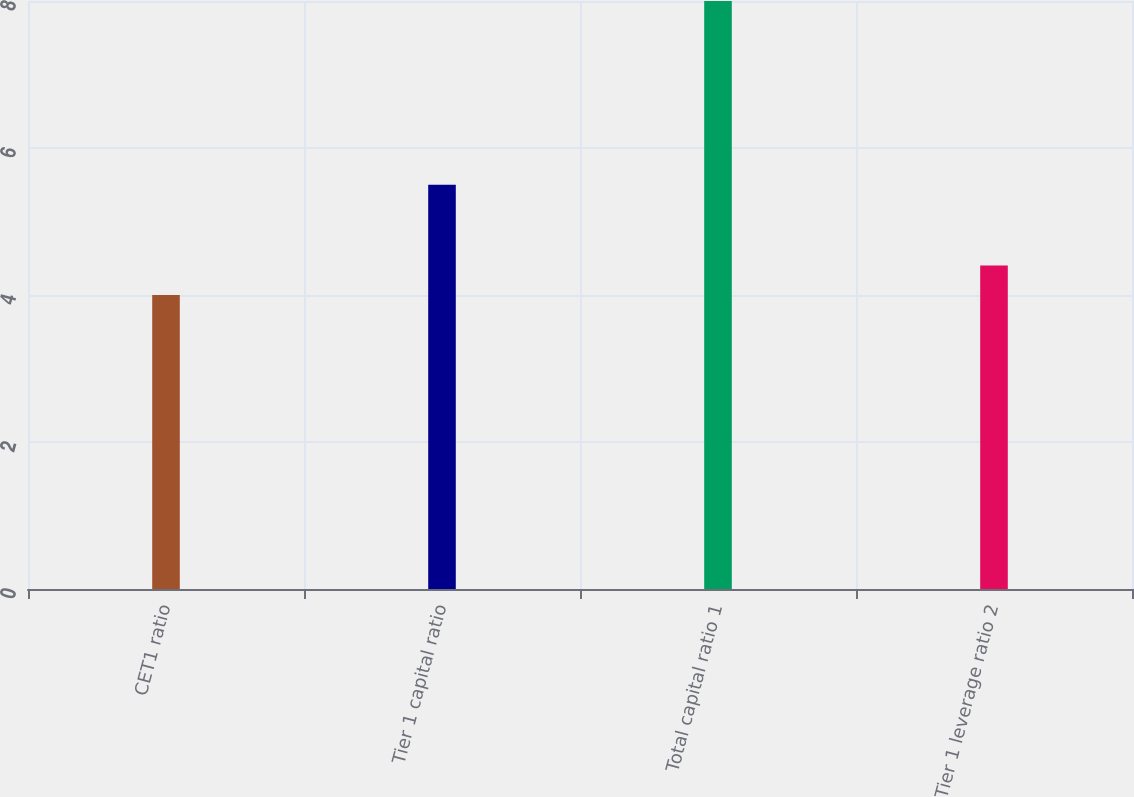<chart> <loc_0><loc_0><loc_500><loc_500><bar_chart><fcel>CET1 ratio<fcel>Tier 1 capital ratio<fcel>Total capital ratio 1<fcel>Tier 1 leverage ratio 2<nl><fcel>4<fcel>5.5<fcel>8<fcel>4.4<nl></chart> 